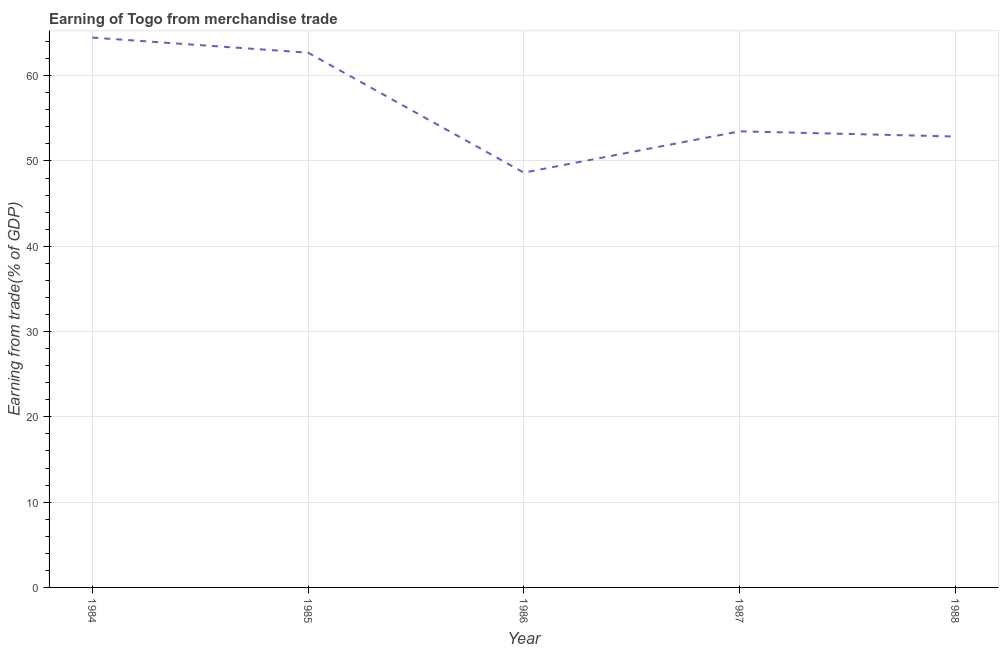What is the earning from merchandise trade in 1988?
Provide a succinct answer. 52.87. Across all years, what is the maximum earning from merchandise trade?
Ensure brevity in your answer.  64.47. Across all years, what is the minimum earning from merchandise trade?
Provide a short and direct response. 48.64. In which year was the earning from merchandise trade minimum?
Offer a terse response. 1986. What is the sum of the earning from merchandise trade?
Provide a succinct answer. 282.16. What is the difference between the earning from merchandise trade in 1986 and 1987?
Provide a succinct answer. -4.84. What is the average earning from merchandise trade per year?
Provide a succinct answer. 56.43. What is the median earning from merchandise trade?
Make the answer very short. 53.48. Do a majority of the years between 1987 and 1988 (inclusive) have earning from merchandise trade greater than 60 %?
Give a very brief answer. No. What is the ratio of the earning from merchandise trade in 1984 to that in 1987?
Offer a terse response. 1.21. Is the earning from merchandise trade in 1985 less than that in 1987?
Your response must be concise. No. What is the difference between the highest and the second highest earning from merchandise trade?
Offer a terse response. 1.77. Is the sum of the earning from merchandise trade in 1986 and 1988 greater than the maximum earning from merchandise trade across all years?
Your answer should be compact. Yes. What is the difference between the highest and the lowest earning from merchandise trade?
Your answer should be very brief. 15.83. In how many years, is the earning from merchandise trade greater than the average earning from merchandise trade taken over all years?
Provide a succinct answer. 2. How many lines are there?
Provide a succinct answer. 1. How many years are there in the graph?
Your answer should be very brief. 5. Does the graph contain any zero values?
Offer a terse response. No. Does the graph contain grids?
Ensure brevity in your answer.  Yes. What is the title of the graph?
Provide a short and direct response. Earning of Togo from merchandise trade. What is the label or title of the X-axis?
Your answer should be compact. Year. What is the label or title of the Y-axis?
Offer a very short reply. Earning from trade(% of GDP). What is the Earning from trade(% of GDP) in 1984?
Make the answer very short. 64.47. What is the Earning from trade(% of GDP) in 1985?
Give a very brief answer. 62.7. What is the Earning from trade(% of GDP) in 1986?
Ensure brevity in your answer.  48.64. What is the Earning from trade(% of GDP) of 1987?
Provide a succinct answer. 53.48. What is the Earning from trade(% of GDP) of 1988?
Provide a succinct answer. 52.87. What is the difference between the Earning from trade(% of GDP) in 1984 and 1985?
Your answer should be very brief. 1.77. What is the difference between the Earning from trade(% of GDP) in 1984 and 1986?
Your answer should be very brief. 15.83. What is the difference between the Earning from trade(% of GDP) in 1984 and 1987?
Ensure brevity in your answer.  10.99. What is the difference between the Earning from trade(% of GDP) in 1984 and 1988?
Ensure brevity in your answer.  11.6. What is the difference between the Earning from trade(% of GDP) in 1985 and 1986?
Provide a short and direct response. 14.06. What is the difference between the Earning from trade(% of GDP) in 1985 and 1987?
Keep it short and to the point. 9.22. What is the difference between the Earning from trade(% of GDP) in 1985 and 1988?
Make the answer very short. 9.83. What is the difference between the Earning from trade(% of GDP) in 1986 and 1987?
Keep it short and to the point. -4.84. What is the difference between the Earning from trade(% of GDP) in 1986 and 1988?
Provide a short and direct response. -4.23. What is the difference between the Earning from trade(% of GDP) in 1987 and 1988?
Ensure brevity in your answer.  0.61. What is the ratio of the Earning from trade(% of GDP) in 1984 to that in 1985?
Give a very brief answer. 1.03. What is the ratio of the Earning from trade(% of GDP) in 1984 to that in 1986?
Your response must be concise. 1.33. What is the ratio of the Earning from trade(% of GDP) in 1984 to that in 1987?
Keep it short and to the point. 1.21. What is the ratio of the Earning from trade(% of GDP) in 1984 to that in 1988?
Ensure brevity in your answer.  1.22. What is the ratio of the Earning from trade(% of GDP) in 1985 to that in 1986?
Provide a short and direct response. 1.29. What is the ratio of the Earning from trade(% of GDP) in 1985 to that in 1987?
Provide a succinct answer. 1.17. What is the ratio of the Earning from trade(% of GDP) in 1985 to that in 1988?
Your answer should be very brief. 1.19. What is the ratio of the Earning from trade(% of GDP) in 1986 to that in 1987?
Your answer should be compact. 0.91. What is the ratio of the Earning from trade(% of GDP) in 1987 to that in 1988?
Keep it short and to the point. 1.01. 